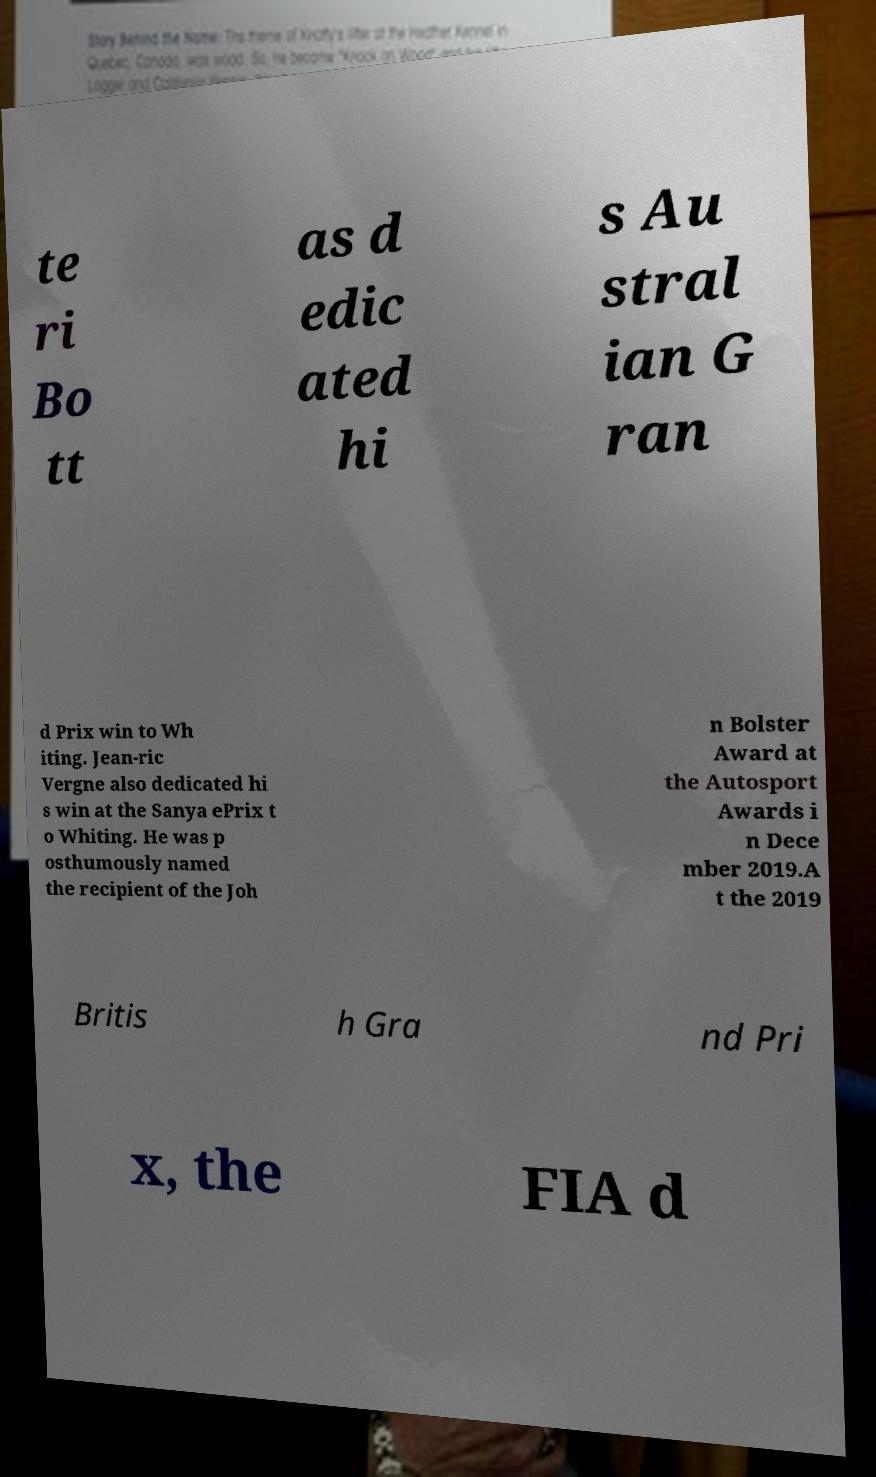Could you assist in decoding the text presented in this image and type it out clearly? te ri Bo tt as d edic ated hi s Au stral ian G ran d Prix win to Wh iting. Jean-ric Vergne also dedicated hi s win at the Sanya ePrix t o Whiting. He was p osthumously named the recipient of the Joh n Bolster Award at the Autosport Awards i n Dece mber 2019.A t the 2019 Britis h Gra nd Pri x, the FIA d 